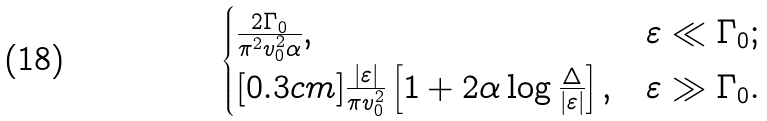Convert formula to latex. <formula><loc_0><loc_0><loc_500><loc_500>\begin{cases} \frac { 2 \Gamma _ { 0 } } { \pi ^ { 2 } v _ { 0 } ^ { 2 } \alpha } , & \varepsilon \ll \Gamma _ { 0 } ; \\ [ 0 . 3 c m ] \frac { | \varepsilon | } { \pi v _ { 0 } ^ { 2 } } \left [ 1 + 2 \alpha \log \frac { \Delta } { | \varepsilon | } \right ] , & \varepsilon \gg \Gamma _ { 0 } . \end{cases}</formula> 